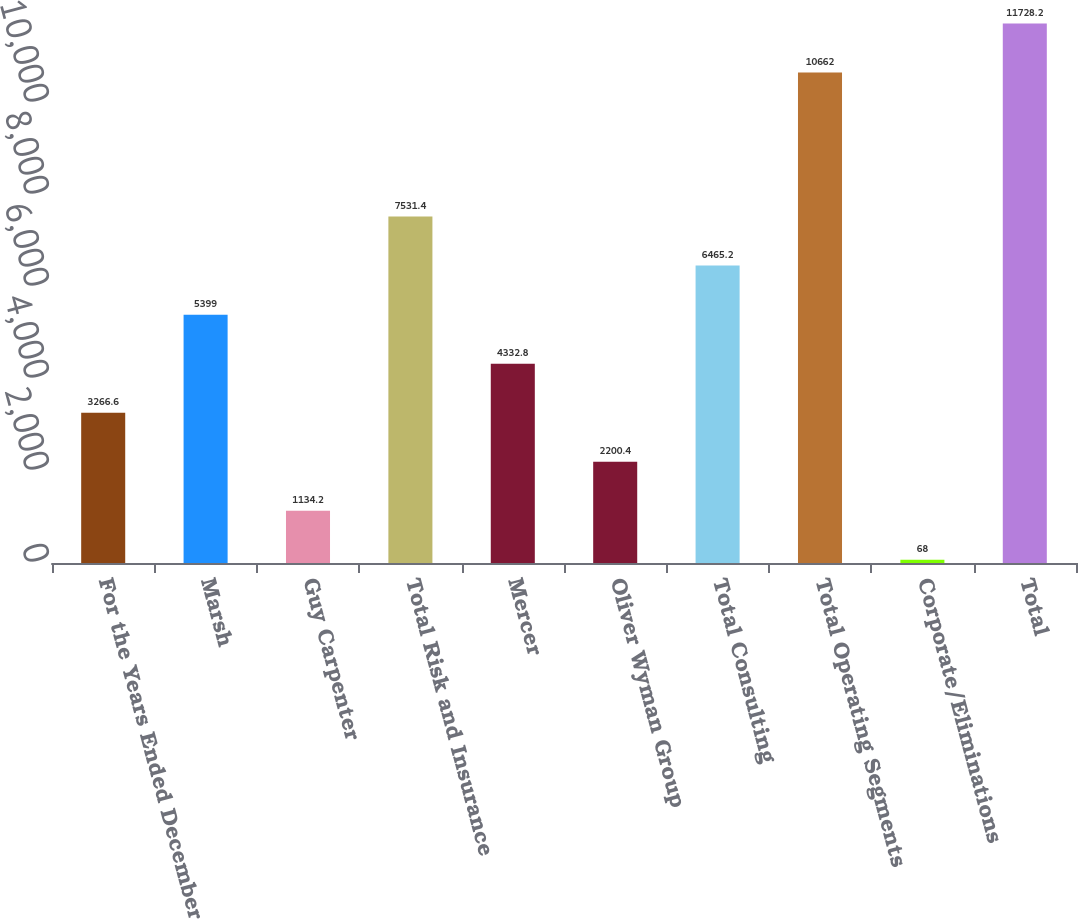Convert chart to OTSL. <chart><loc_0><loc_0><loc_500><loc_500><bar_chart><fcel>For the Years Ended December<fcel>Marsh<fcel>Guy Carpenter<fcel>Total Risk and Insurance<fcel>Mercer<fcel>Oliver Wyman Group<fcel>Total Consulting<fcel>Total Operating Segments<fcel>Corporate/Eliminations<fcel>Total<nl><fcel>3266.6<fcel>5399<fcel>1134.2<fcel>7531.4<fcel>4332.8<fcel>2200.4<fcel>6465.2<fcel>10662<fcel>68<fcel>11728.2<nl></chart> 